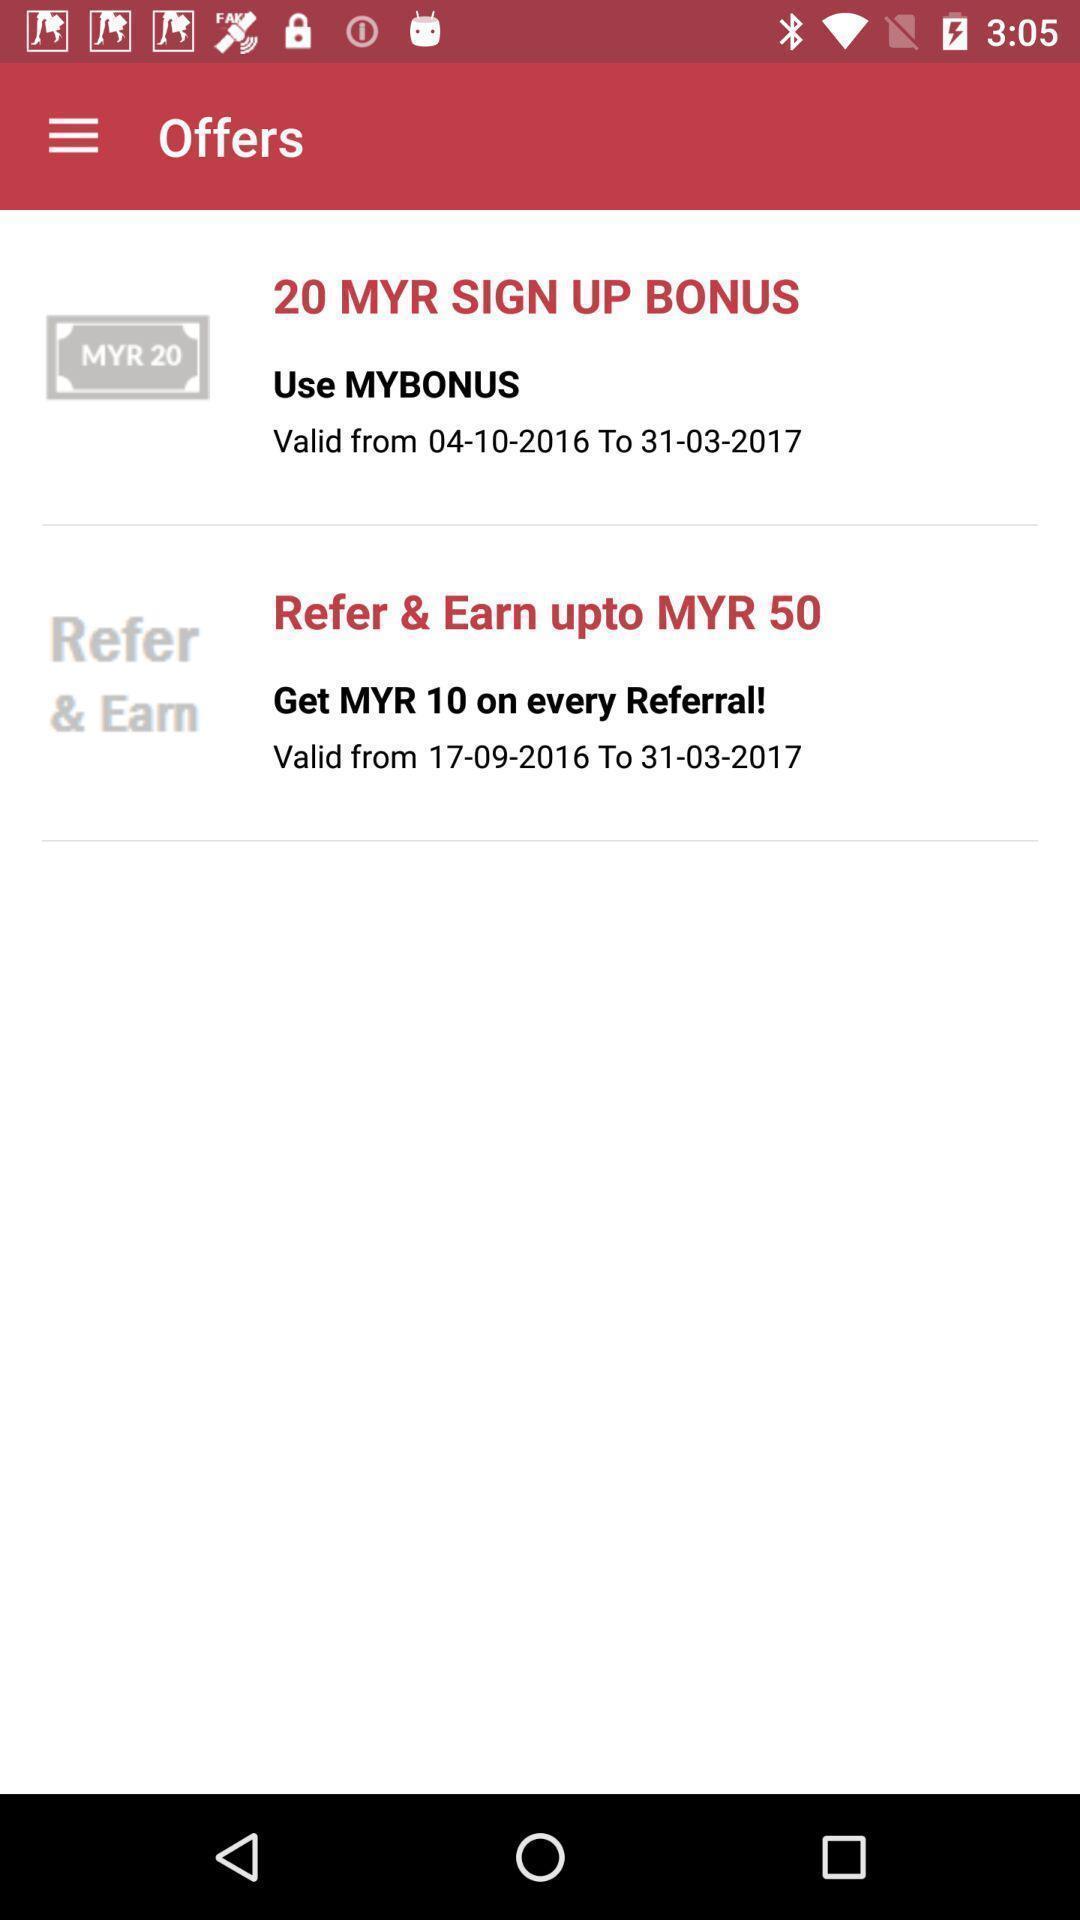Describe the key features of this screenshot. Various types of offers in the application. 